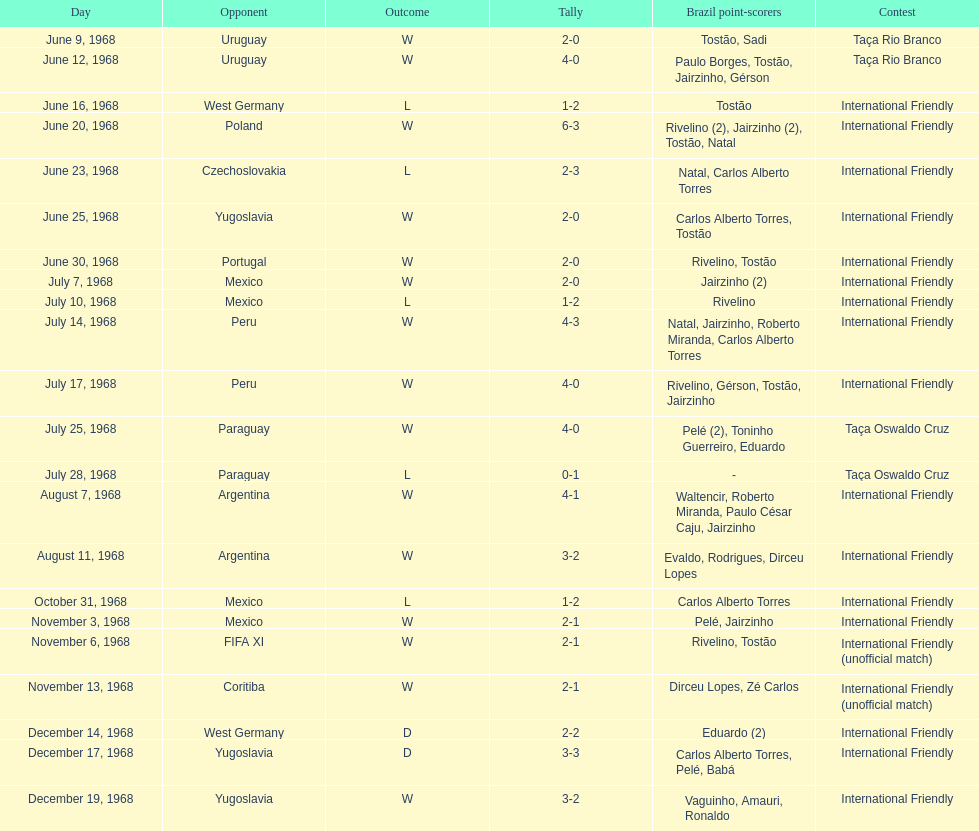Total number of wins 15. Can you parse all the data within this table? {'header': ['Day', 'Opponent', 'Outcome', 'Tally', 'Brazil point-scorers', 'Contest'], 'rows': [['June 9, 1968', 'Uruguay', 'W', '2-0', 'Tostão, Sadi', 'Taça Rio Branco'], ['June 12, 1968', 'Uruguay', 'W', '4-0', 'Paulo Borges, Tostão, Jairzinho, Gérson', 'Taça Rio Branco'], ['June 16, 1968', 'West Germany', 'L', '1-2', 'Tostão', 'International Friendly'], ['June 20, 1968', 'Poland', 'W', '6-3', 'Rivelino (2), Jairzinho (2), Tostão, Natal', 'International Friendly'], ['June 23, 1968', 'Czechoslovakia', 'L', '2-3', 'Natal, Carlos Alberto Torres', 'International Friendly'], ['June 25, 1968', 'Yugoslavia', 'W', '2-0', 'Carlos Alberto Torres, Tostão', 'International Friendly'], ['June 30, 1968', 'Portugal', 'W', '2-0', 'Rivelino, Tostão', 'International Friendly'], ['July 7, 1968', 'Mexico', 'W', '2-0', 'Jairzinho (2)', 'International Friendly'], ['July 10, 1968', 'Mexico', 'L', '1-2', 'Rivelino', 'International Friendly'], ['July 14, 1968', 'Peru', 'W', '4-3', 'Natal, Jairzinho, Roberto Miranda, Carlos Alberto Torres', 'International Friendly'], ['July 17, 1968', 'Peru', 'W', '4-0', 'Rivelino, Gérson, Tostão, Jairzinho', 'International Friendly'], ['July 25, 1968', 'Paraguay', 'W', '4-0', 'Pelé (2), Toninho Guerreiro, Eduardo', 'Taça Oswaldo Cruz'], ['July 28, 1968', 'Paraguay', 'L', '0-1', '-', 'Taça Oswaldo Cruz'], ['August 7, 1968', 'Argentina', 'W', '4-1', 'Waltencir, Roberto Miranda, Paulo César Caju, Jairzinho', 'International Friendly'], ['August 11, 1968', 'Argentina', 'W', '3-2', 'Evaldo, Rodrigues, Dirceu Lopes', 'International Friendly'], ['October 31, 1968', 'Mexico', 'L', '1-2', 'Carlos Alberto Torres', 'International Friendly'], ['November 3, 1968', 'Mexico', 'W', '2-1', 'Pelé, Jairzinho', 'International Friendly'], ['November 6, 1968', 'FIFA XI', 'W', '2-1', 'Rivelino, Tostão', 'International Friendly (unofficial match)'], ['November 13, 1968', 'Coritiba', 'W', '2-1', 'Dirceu Lopes, Zé Carlos', 'International Friendly (unofficial match)'], ['December 14, 1968', 'West Germany', 'D', '2-2', 'Eduardo (2)', 'International Friendly'], ['December 17, 1968', 'Yugoslavia', 'D', '3-3', 'Carlos Alberto Torres, Pelé, Babá', 'International Friendly'], ['December 19, 1968', 'Yugoslavia', 'W', '3-2', 'Vaguinho, Amauri, Ronaldo', 'International Friendly']]} 